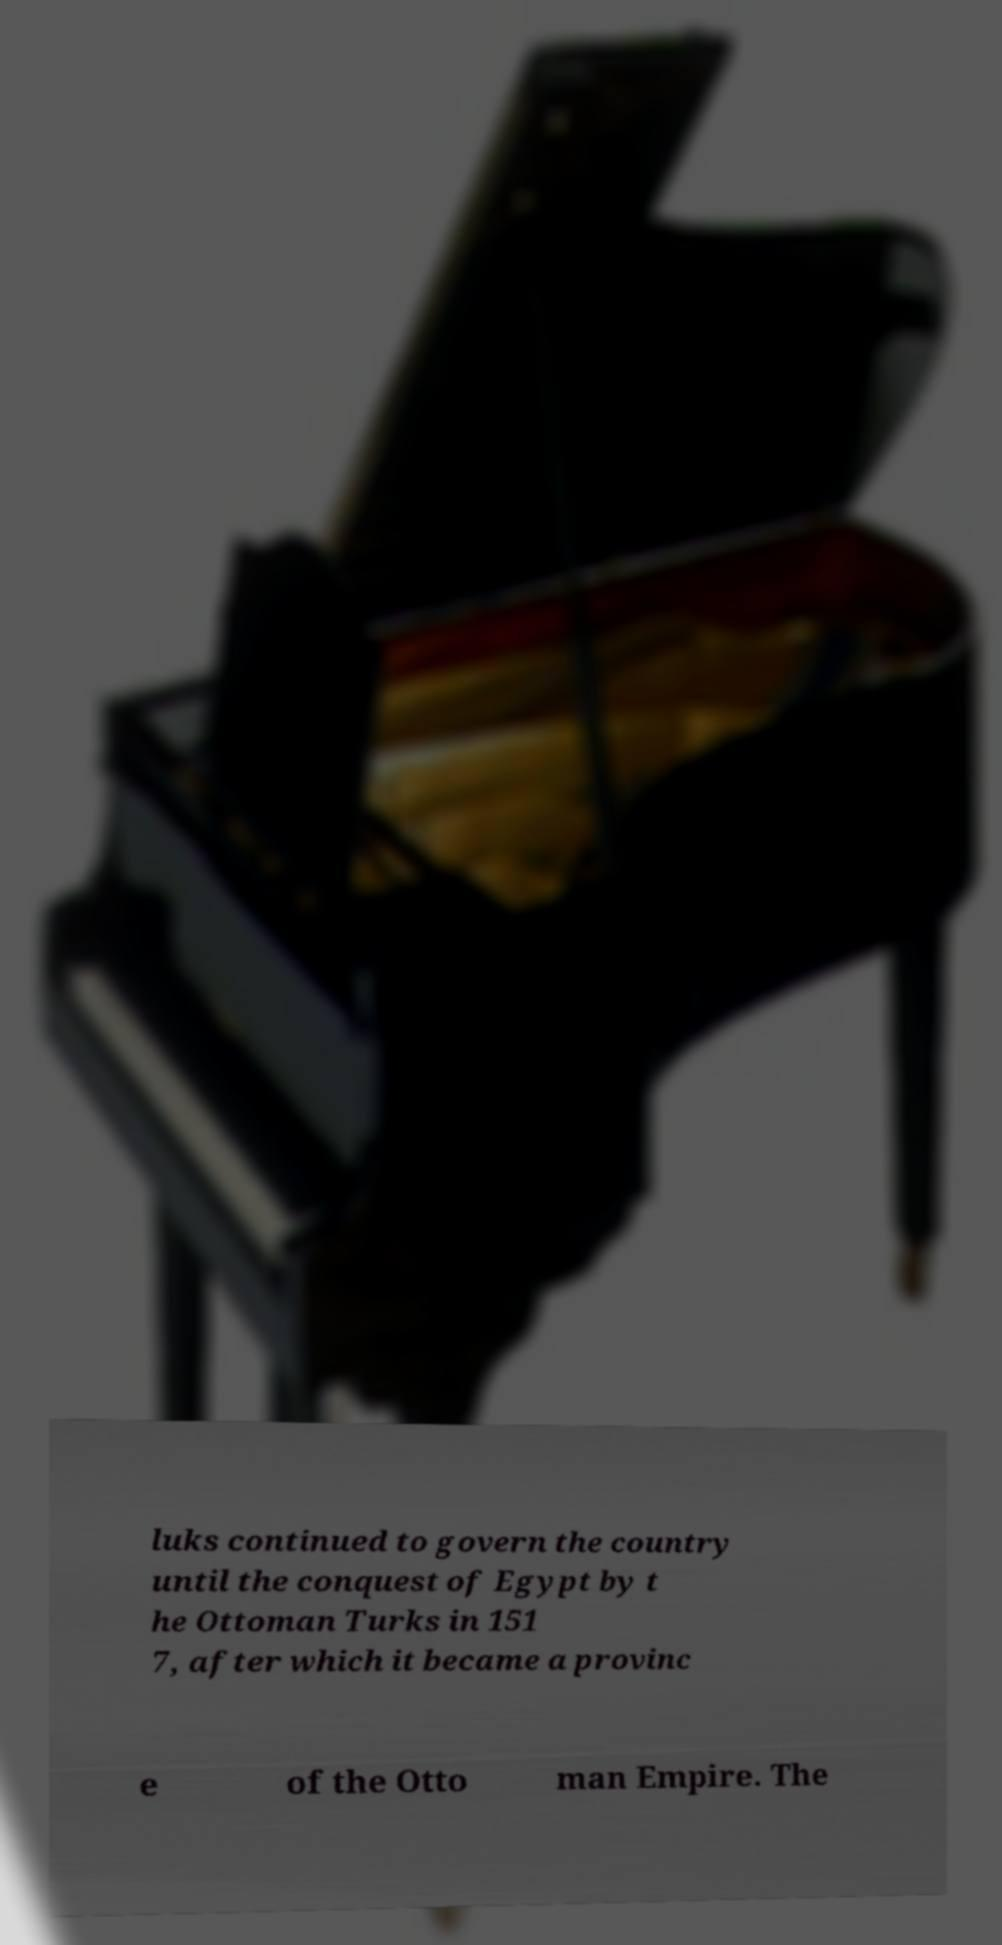Can you read and provide the text displayed in the image?This photo seems to have some interesting text. Can you extract and type it out for me? luks continued to govern the country until the conquest of Egypt by t he Ottoman Turks in 151 7, after which it became a provinc e of the Otto man Empire. The 